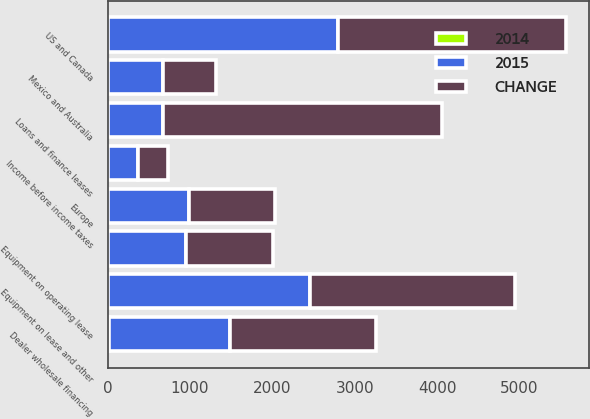Convert chart. <chart><loc_0><loc_0><loc_500><loc_500><stacked_bar_chart><ecel><fcel>US and Canada<fcel>Europe<fcel>Mexico and Australia<fcel>Loans and finance leases<fcel>Equipment on operating lease<fcel>Dealer wholesale financing<fcel>Equipment on lease and other<fcel>Income before income taxes<nl><fcel>CHANGE<fcel>2758.7<fcel>1039<fcel>639.5<fcel>3383<fcel>1054.2<fcel>1775.2<fcel>2492.2<fcel>362.6<nl><fcel>2015<fcel>2798.3<fcel>988.1<fcel>668.7<fcel>668.7<fcel>938.4<fcel>1462<fcel>2452.9<fcel>370.4<nl><fcel>2014<fcel>1<fcel>5<fcel>4<fcel>4<fcel>12<fcel>21<fcel>2<fcel>2<nl></chart> 